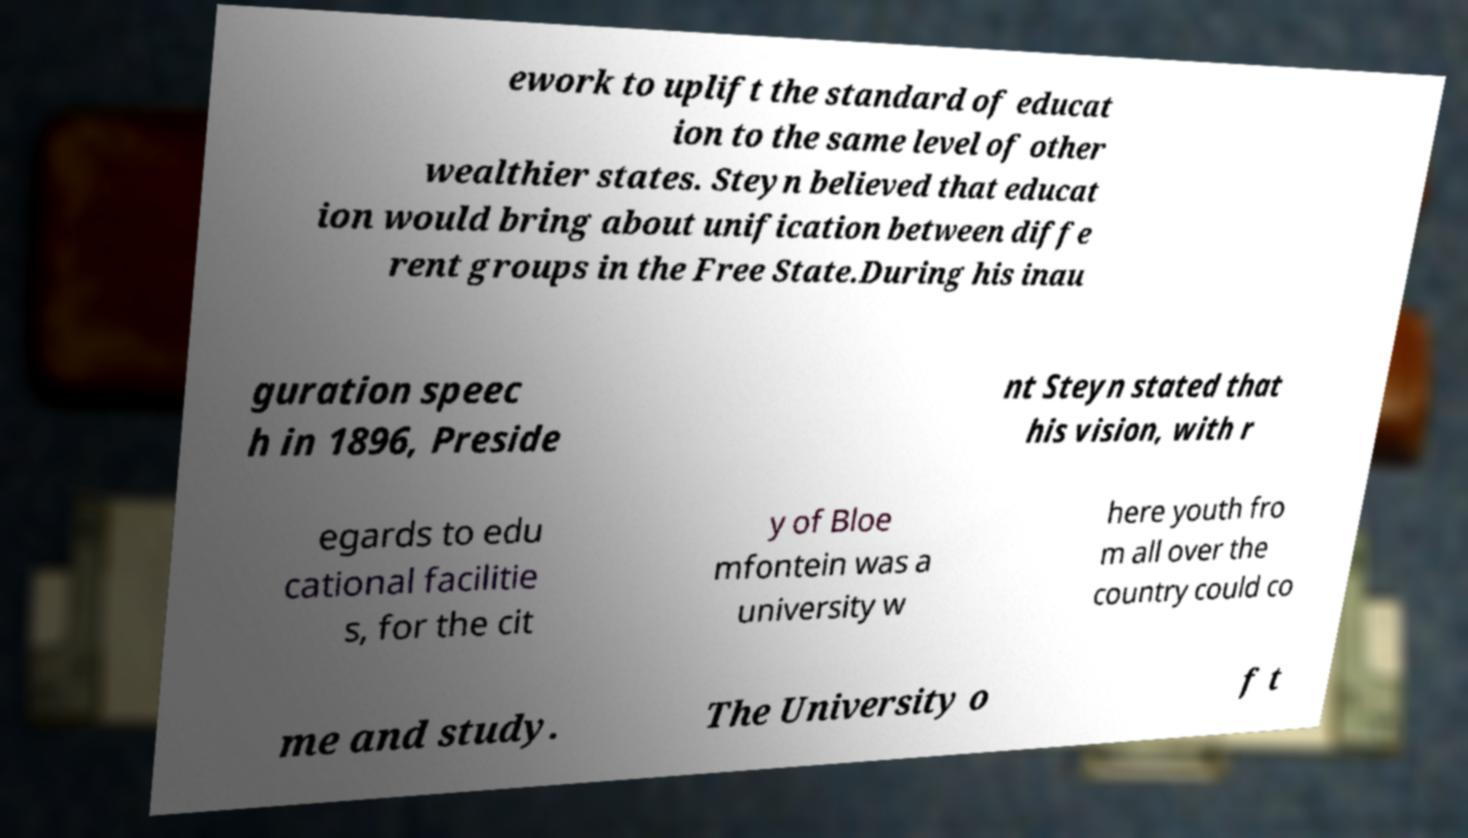For documentation purposes, I need the text within this image transcribed. Could you provide that? ework to uplift the standard of educat ion to the same level of other wealthier states. Steyn believed that educat ion would bring about unification between diffe rent groups in the Free State.During his inau guration speec h in 1896, Preside nt Steyn stated that his vision, with r egards to edu cational facilitie s, for the cit y of Bloe mfontein was a university w here youth fro m all over the country could co me and study. The University o f t 